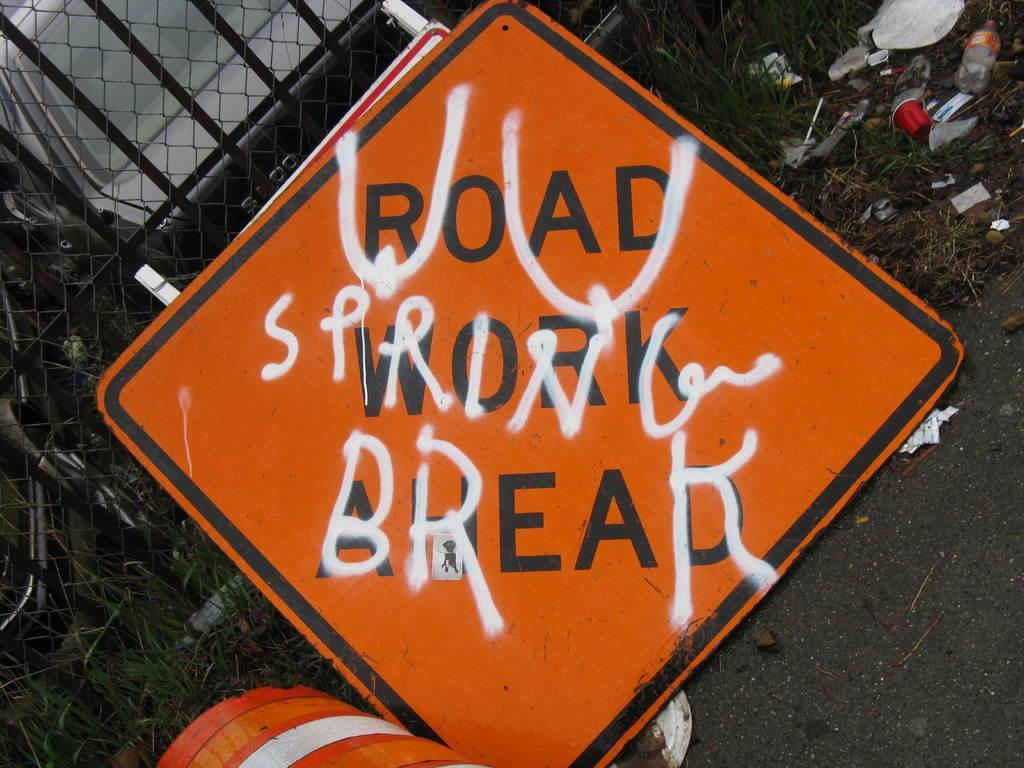In one or two sentences, can you explain what this image depicts? In the image we can see road, grass, fence, vehicle and a board, on the board there is a text. This is a trash. 